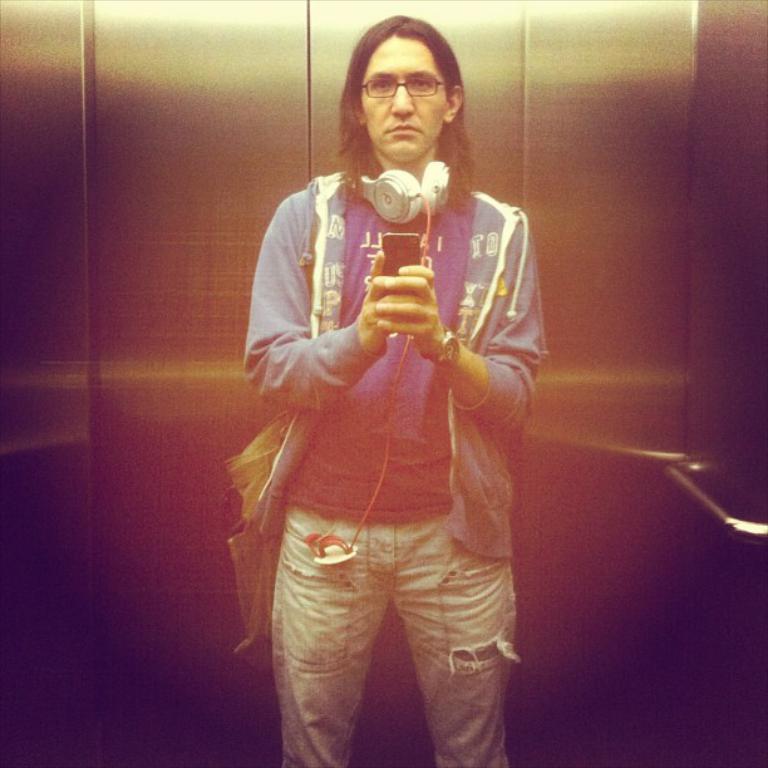Can you describe this image briefly? In this image, we can see a person wearing headphones on her neck. This person is wearing clothes and holding a phone with her hands. There is a handle on the right side of the image. 